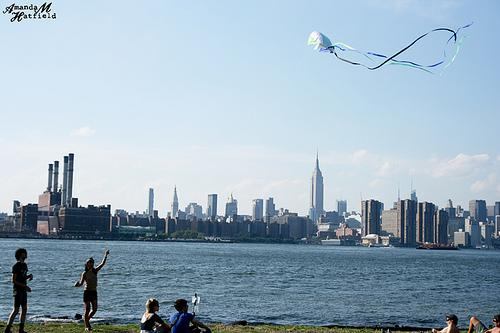Tell me how many people are in the image and what two of them are doing. There are at least seven people in the image. The woman is pointing at the kite, and two people are sitting on the grass. Analyze the interaction between the people and the kite in the image, considering their positions and actions. The people are engaged with the kite in various ways - the woman is pointing at it while the kids are watching it, and other people seem to be enjoying its presence as they sit or lay on the grass. The kite appears to be the focal point of the scene, connecting people and creating shared experiences. What is the sentiment of the image involving people's interaction with each other and their environment? The sentiment of the image is positive, with people enjoying their time outdoors, interacting with each other, and engaging with the environment, such as observing a kite in the sky. Describe a complex reasoning task involving people and objects in the image. Determine the possible route the woman's line of sight takes as she points towards the kite, considering the possible positions of other people, such as the kids watching the kite and the man standing on the shore. Which natural elements are depicted in the image and provide a description of one of them? Natural elements in the image include the sky, clouds, ocean, and grass. The grass is green and part of a larger grassy shore along the ocean. Can you describe the kite in the sky and what it seems like the wind is doing to it? The kite is white, and it appears that the wind is blowing it, as indicated by the streamers trailing behind it. What is the quality of the image in terms of clarity and number of features provided? The quality of the image seems to be high, with many features and objects clearly defined, such as people, buildings, ocean, grass, and sky. Count the total number of objects described in the image and provide an example of two different types of objects. There are approximately 43 objects described in the image, with examples including a kite in the sky and buildings near the water. What type of landscape is the image set in, and what is one prominent feature of this landscape? The image is set in a coastal landscape, with a blue ocean and green grassy shore as prominent features. Identify the various actions performed by people in the image. Some actions performed by people include: pointing, watching, laying on the grass, sitting near water, standing, running, and holding up a hand. Are the people lying on the grass wearing hats? There is no mention of hats in any of the captions about people lying on the grass. Does the woman pointing at the kite have an umbrella? The captions about the woman pointing at the kite do not mention her having an umbrella. Are the clouds in the sky dark and stormy? There is no mention of the clouds being dark or stormy in any of the captions; the sky is described as blue in one instance. Are the buildings made of wood near the water? None of the captions mention the material of the buildings near the water. Can you see a dog playing in the park? None of the captions mention a dog being present in the image. Is the kite in the sky a bright red color? There is no mention of a red color for the kite in any caption; it's referred to as "white" in one instance. 